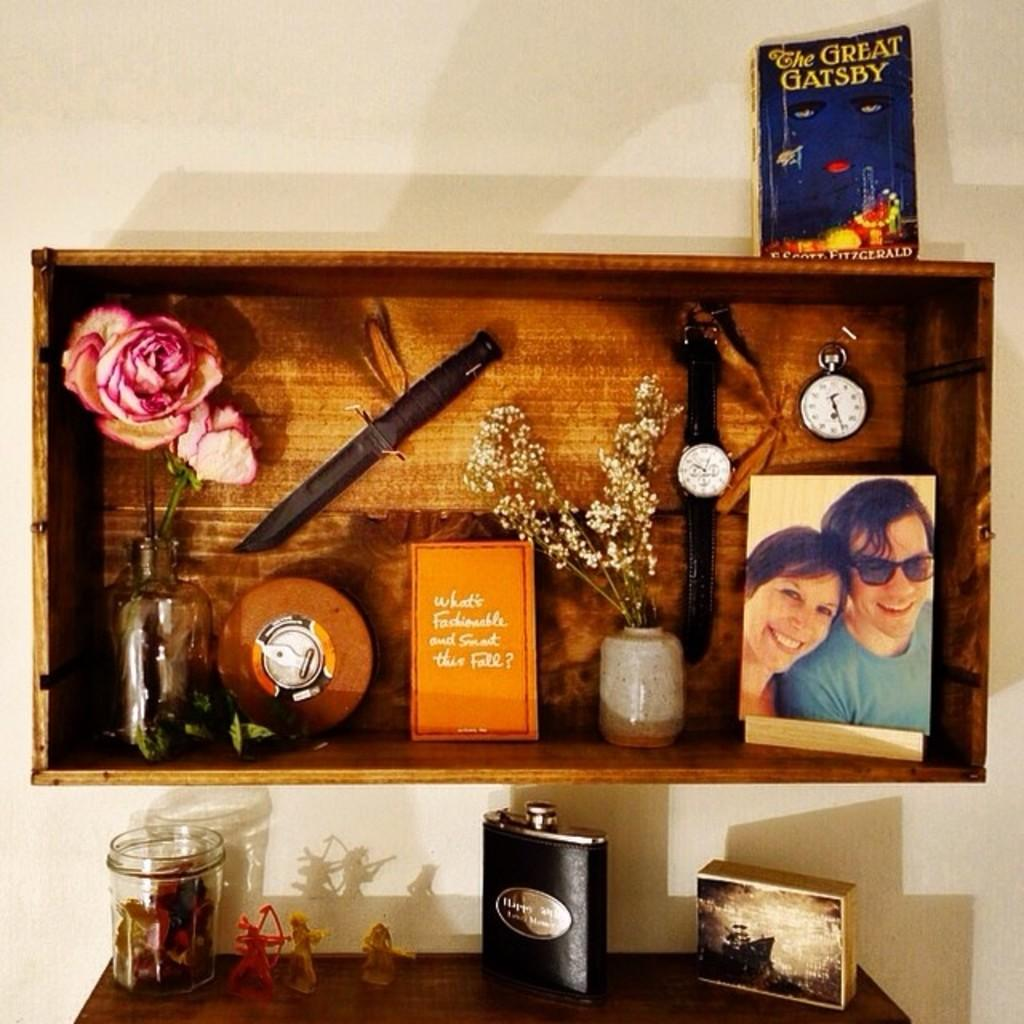<image>
Relay a brief, clear account of the picture shown. A copy of the Great Gatsby on top of wall unit with various keepsake in it 